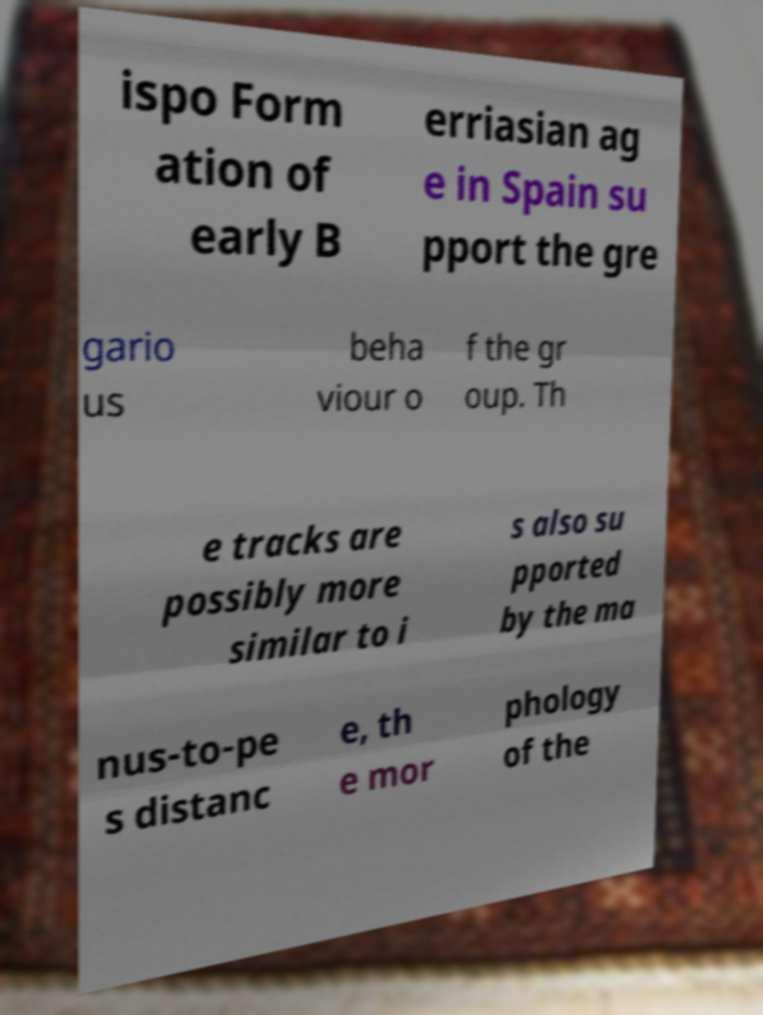Can you read and provide the text displayed in the image?This photo seems to have some interesting text. Can you extract and type it out for me? ispo Form ation of early B erriasian ag e in Spain su pport the gre gario us beha viour o f the gr oup. Th e tracks are possibly more similar to i s also su pported by the ma nus-to-pe s distanc e, th e mor phology of the 